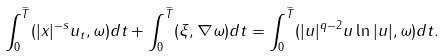<formula> <loc_0><loc_0><loc_500><loc_500>\int _ { 0 } ^ { \widetilde { T } } ( | x | ^ { - s } u _ { t } , \omega ) d t + \int _ { 0 } ^ { \widetilde { T } } ( \xi , \nabla \omega ) d t = \int _ { 0 } ^ { \widetilde { T } } ( | u | ^ { q - 2 } u \ln | u | , \omega ) d t .</formula> 